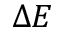<formula> <loc_0><loc_0><loc_500><loc_500>\Delta E</formula> 